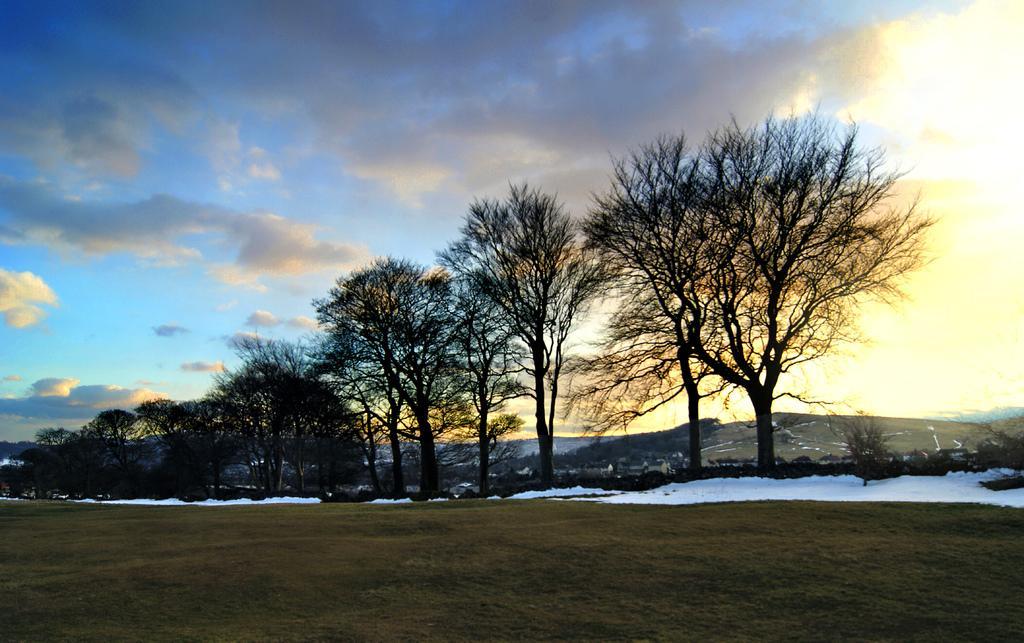Can you describe this image briefly? In this picture we can see some dry trees in the middle of the ground. In the front we can see the ground and some snow. On the top we can see the sky and clouds. 